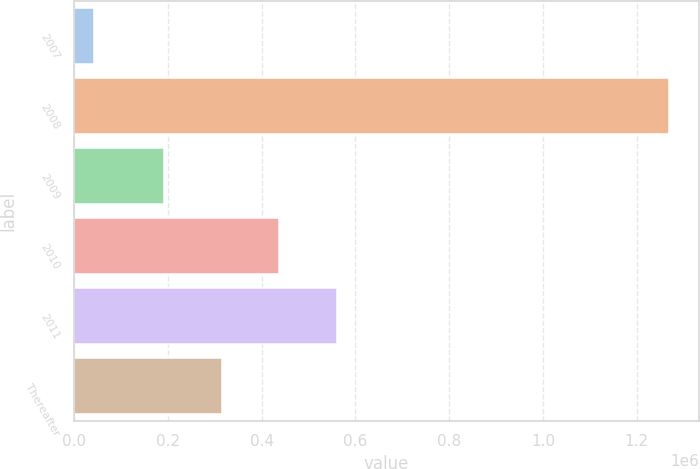Convert chart to OTSL. <chart><loc_0><loc_0><loc_500><loc_500><bar_chart><fcel>2007<fcel>2008<fcel>2009<fcel>2010<fcel>2011<fcel>Thereafter<nl><fcel>41492<fcel>1.26867e+06<fcel>191982<fcel>437418<fcel>560136<fcel>314700<nl></chart> 